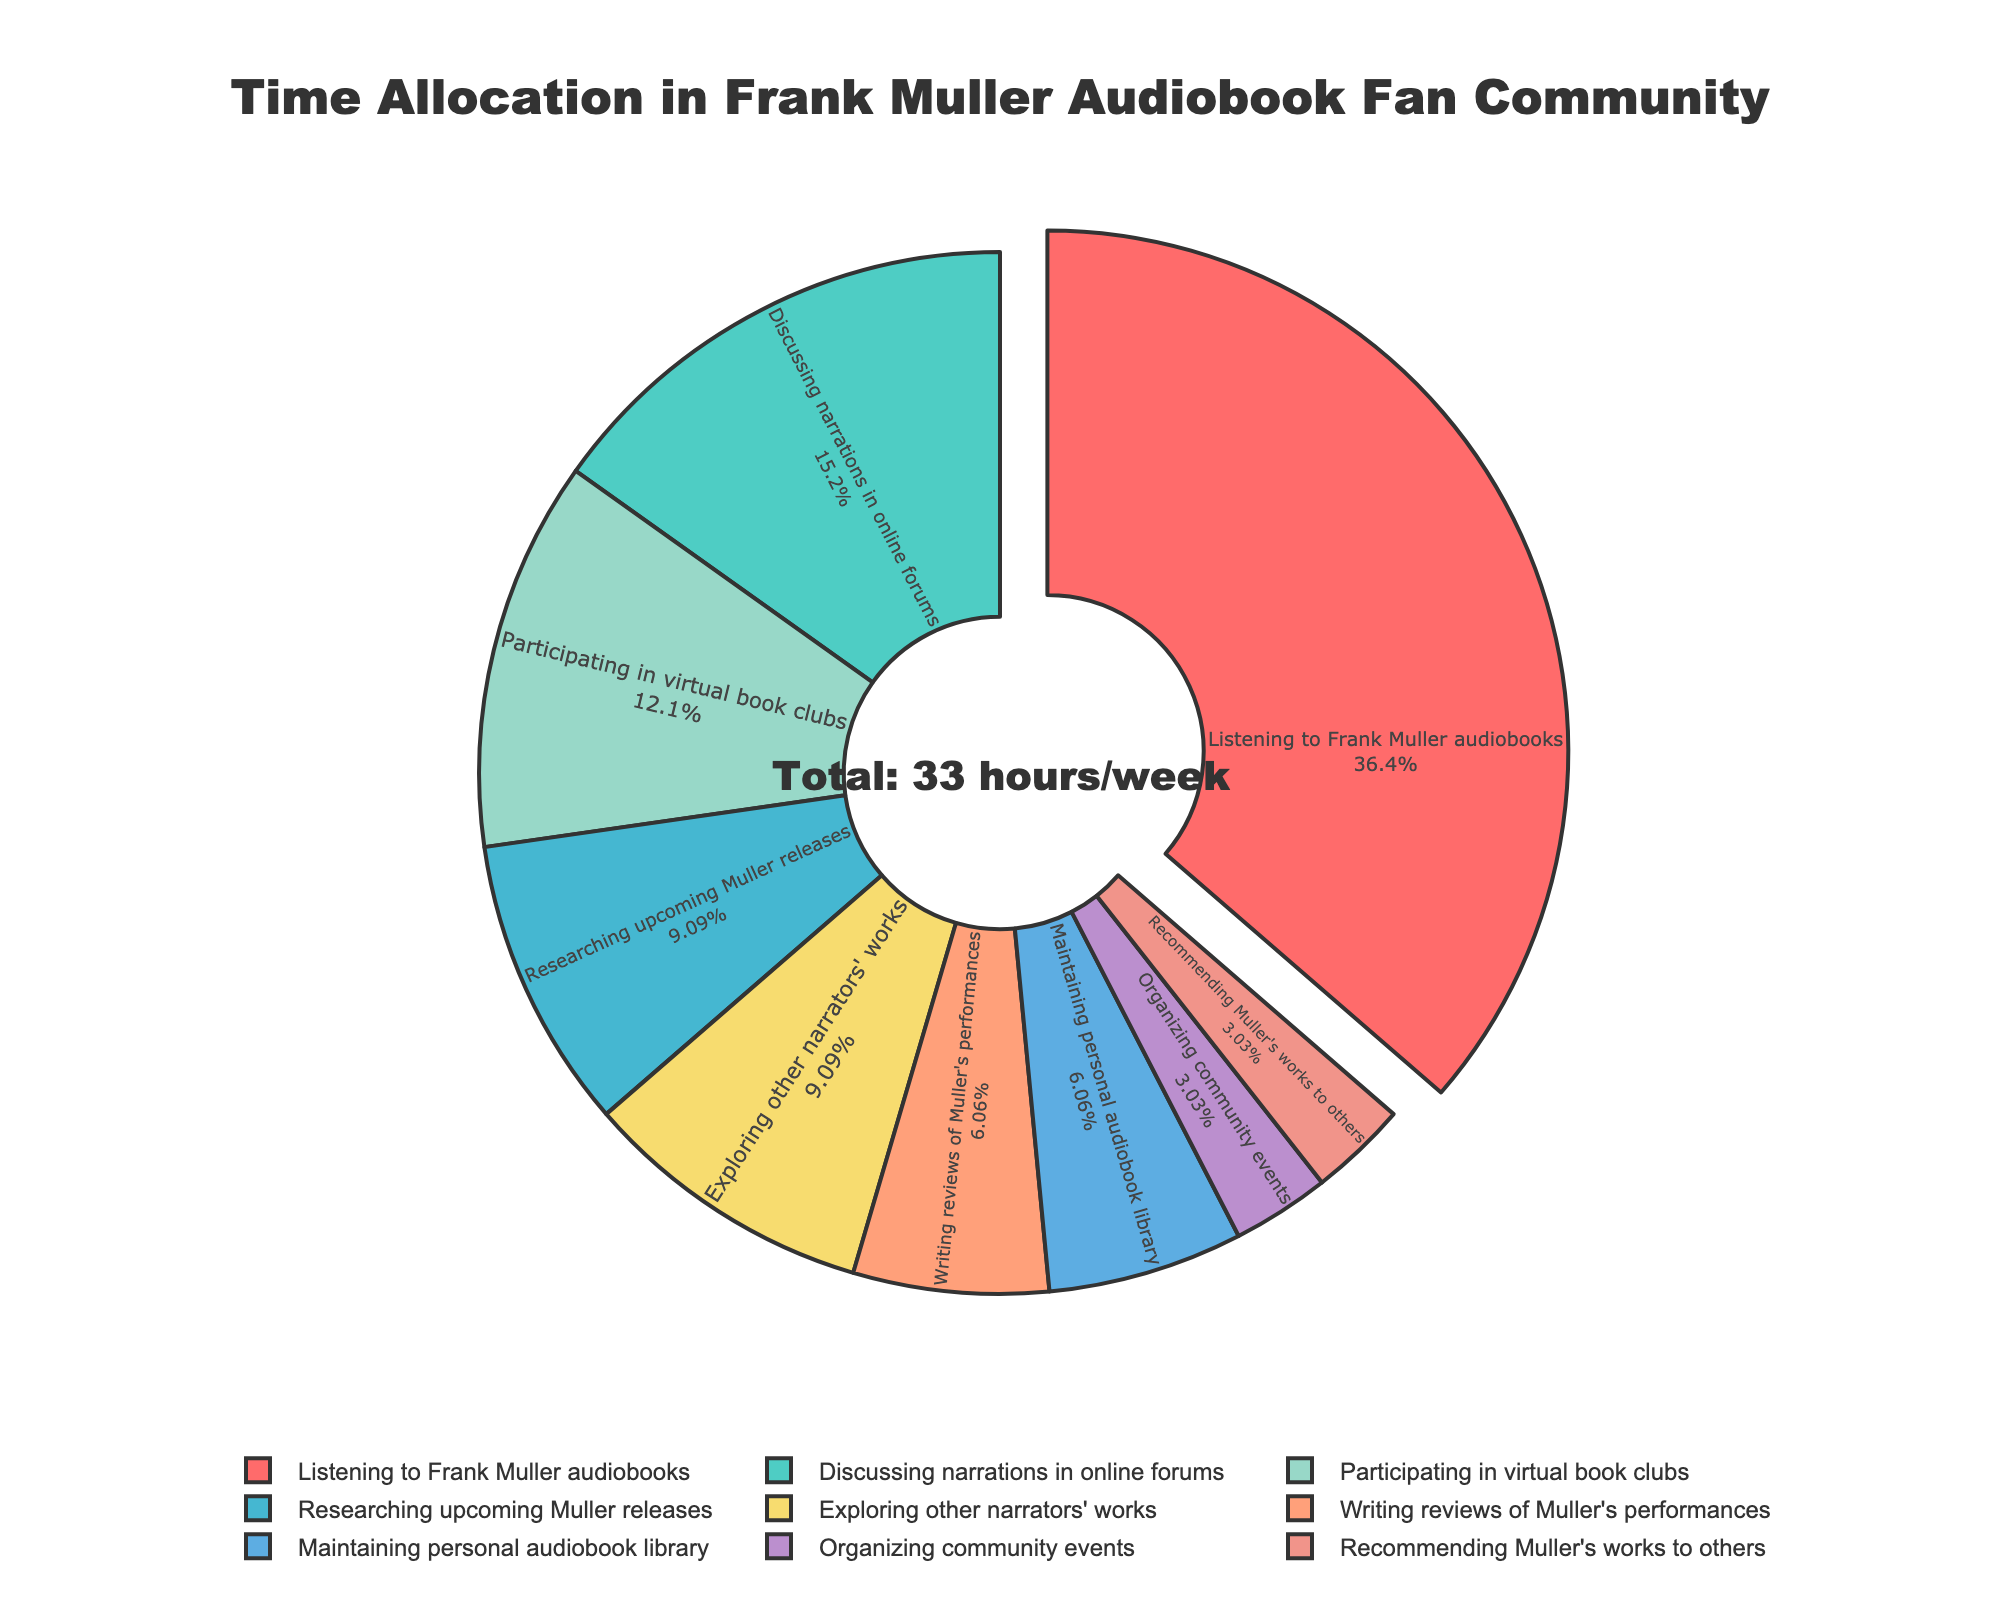Which activity takes up the most time per week? The activity that takes up the most time can be identified by the largest slice of the pie chart, which is "Listening to Frank Muller audiobooks."
Answer: Listening to Frank Muller audiobooks What percentage of the total time is spent on discussing narrations in online forums? The percentage of time spent can be seen directly on the pie chart. The slice labeled "Discussing narrations in online forums" shows this percentage.
Answer: 15.15% How many hours per week are spent on activities other than listening to audiobooks? To find this, we need to sum up the hours spent on all activities except "Listening to Frank Muller audiobooks". All the other activities have hours that sum up to 5 + 3 + 2 + 4 + 3 + 1 + 2 + 1 = 21 hours.
Answer: 21 hours What is the combined percentage of time spent on exploring other narrators' works and writing reviews of Muller's performances? Find the percentages of both activities from the pie chart and then sum them up. Exploring other narrators' works is 9.09% and writing reviews is 6.06%, so combined it is 9.09% + 6.06% = 15.15%.
Answer: 15.15% Which activity takes up less time, maintaining a personal audiobook library or organizing community events? Compare the sizes of the slices labeled "Maintaining personal audiobook library" and "Organizing community events." "Organizing community events" takes up less time.
Answer: Organizing community events What is the percentage difference between the time spent on researching upcoming Muller releases and participating in virtual book clubs? The percentages for researching upcoming releases and participating in virtual book clubs can be found on the pie chart. Researching is 9.09% and participating in virtual book clubs is 12.12%. The percentage difference is 12.12% - 9.09% = 3.03%.
Answer: 3.03% How many activities take up exactly 1 hour per week? The number of activities that take up 1 hour per week can be identified from the pie chart. There are two such activities: "Organizing community events" and "Recommending Muller's works to others."
Answer: 2 activities If we combine the activities listed under writing reviews and maintaining the personal audiobook library, what fraction of the total weekly hours do they take up? Sum up the hours for "Writing reviews of Muller's performances" (2 hours) and "Maintaining personal audiobook library" (2 hours). They total 2 + 2 = 4 hours. The total available hours is 33. So the fraction is 4/33.
Answer: 4/33 